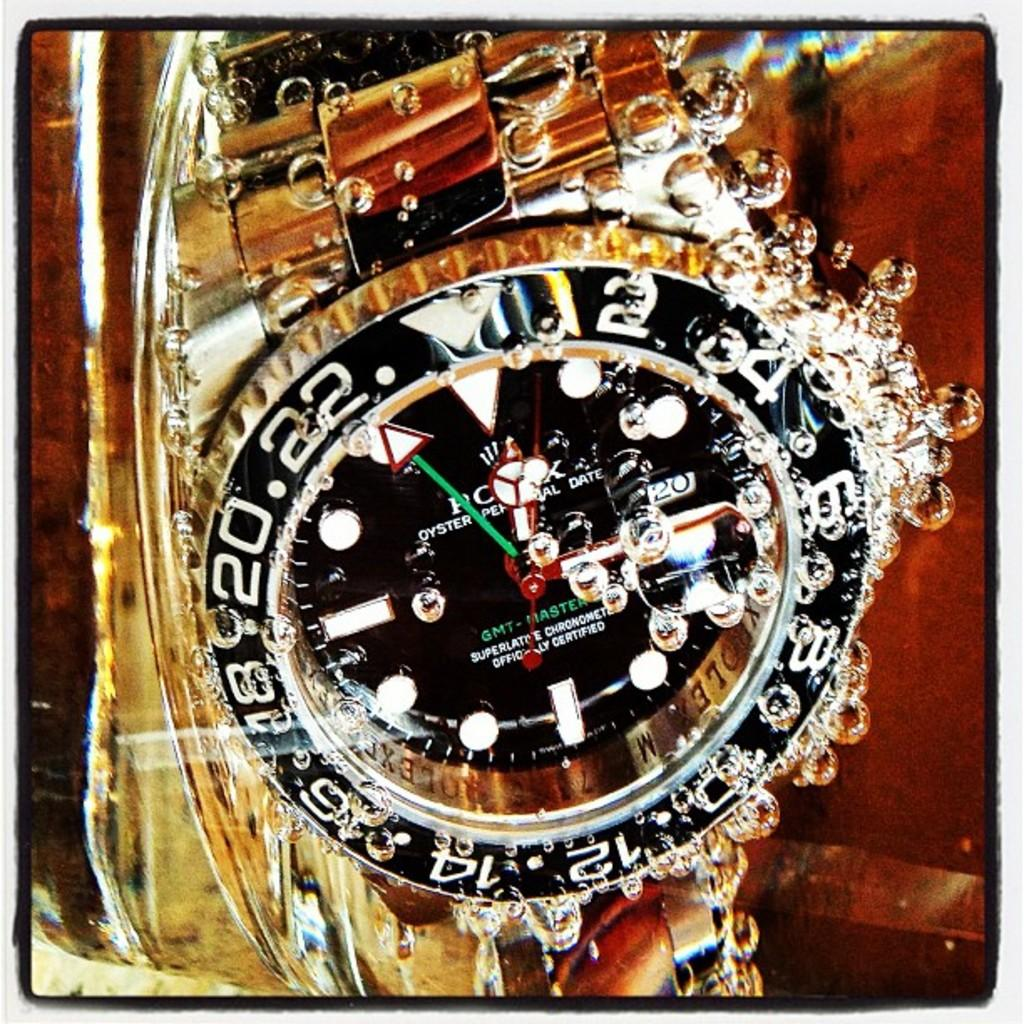Provide a one-sentence caption for the provided image. A gold wristwatch submerged in water and it says it is officially certified. 